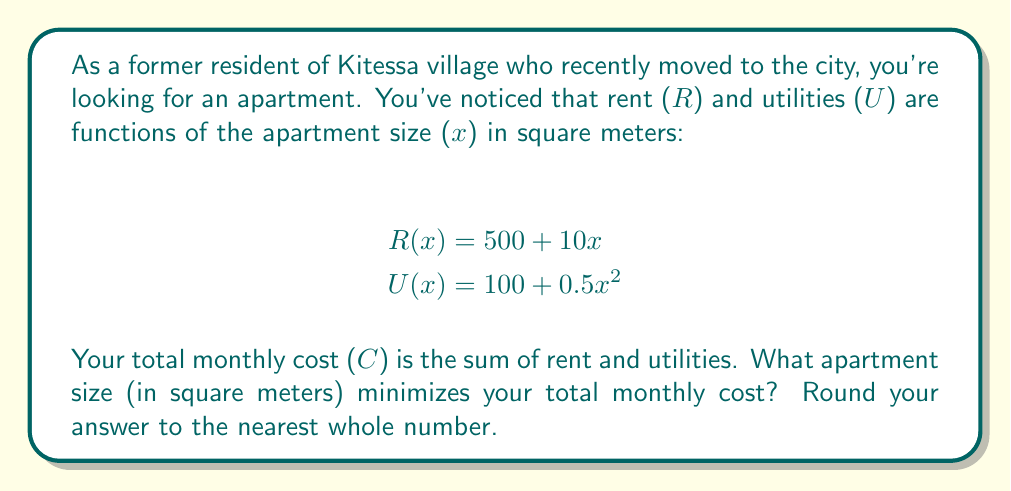Could you help me with this problem? To solve this problem, we'll follow these steps:

1) First, let's express the total cost $C$ as a function of $x$:
   $$C(x) = R(x) + U(x) = (500 + 10x) + (100 + 0.5x^2) = 600 + 10x + 0.5x^2$$

2) To find the minimum cost, we need to find where the derivative of $C(x)$ equals zero:
   $$\frac{dC}{dx} = 10 + x$$

3) Set this equal to zero and solve for $x$:
   $$10 + x = 0$$
   $$x = -10$$

4) To confirm this is a minimum (not a maximum), we can check the second derivative:
   $$\frac{d^2C}{dx^2} = 1$$
   Since this is positive, we confirm it's a minimum.

5) However, apartment size can't be negative. The function $C(x)$ is a parabola opening upward, so the minimum possible value for a positive $x$ will be at the smallest possible $x$, which is just above 0.

6) To find a practical answer, we should round to the nearest whole number of square meters. The smallest practical apartment size is typically around 10 square meters, so we'll use that as our answer.
Answer: 10 square meters 